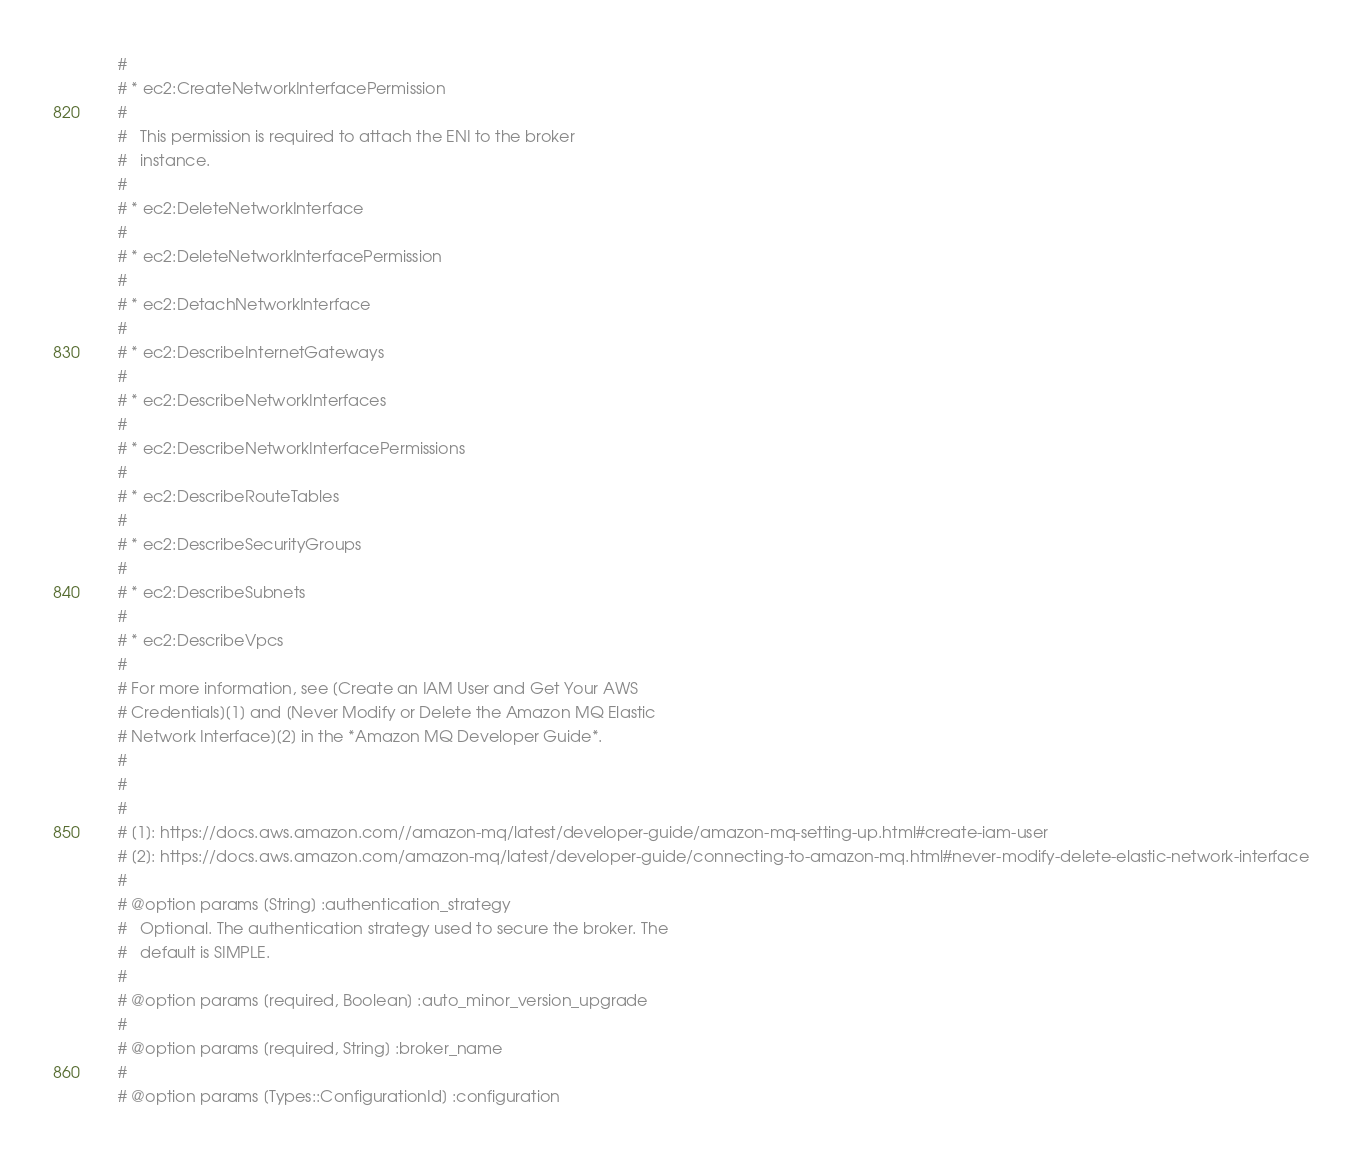<code> <loc_0><loc_0><loc_500><loc_500><_Ruby_>    #
    # * ec2:CreateNetworkInterfacePermission
    #
    #   This permission is required to attach the ENI to the broker
    #   instance.
    #
    # * ec2:DeleteNetworkInterface
    #
    # * ec2:DeleteNetworkInterfacePermission
    #
    # * ec2:DetachNetworkInterface
    #
    # * ec2:DescribeInternetGateways
    #
    # * ec2:DescribeNetworkInterfaces
    #
    # * ec2:DescribeNetworkInterfacePermissions
    #
    # * ec2:DescribeRouteTables
    #
    # * ec2:DescribeSecurityGroups
    #
    # * ec2:DescribeSubnets
    #
    # * ec2:DescribeVpcs
    #
    # For more information, see [Create an IAM User and Get Your AWS
    # Credentials][1] and [Never Modify or Delete the Amazon MQ Elastic
    # Network Interface][2] in the *Amazon MQ Developer Guide*.
    #
    #
    #
    # [1]: https://docs.aws.amazon.com//amazon-mq/latest/developer-guide/amazon-mq-setting-up.html#create-iam-user
    # [2]: https://docs.aws.amazon.com/amazon-mq/latest/developer-guide/connecting-to-amazon-mq.html#never-modify-delete-elastic-network-interface
    #
    # @option params [String] :authentication_strategy
    #   Optional. The authentication strategy used to secure the broker. The
    #   default is SIMPLE.
    #
    # @option params [required, Boolean] :auto_minor_version_upgrade
    #
    # @option params [required, String] :broker_name
    #
    # @option params [Types::ConfigurationId] :configuration</code> 